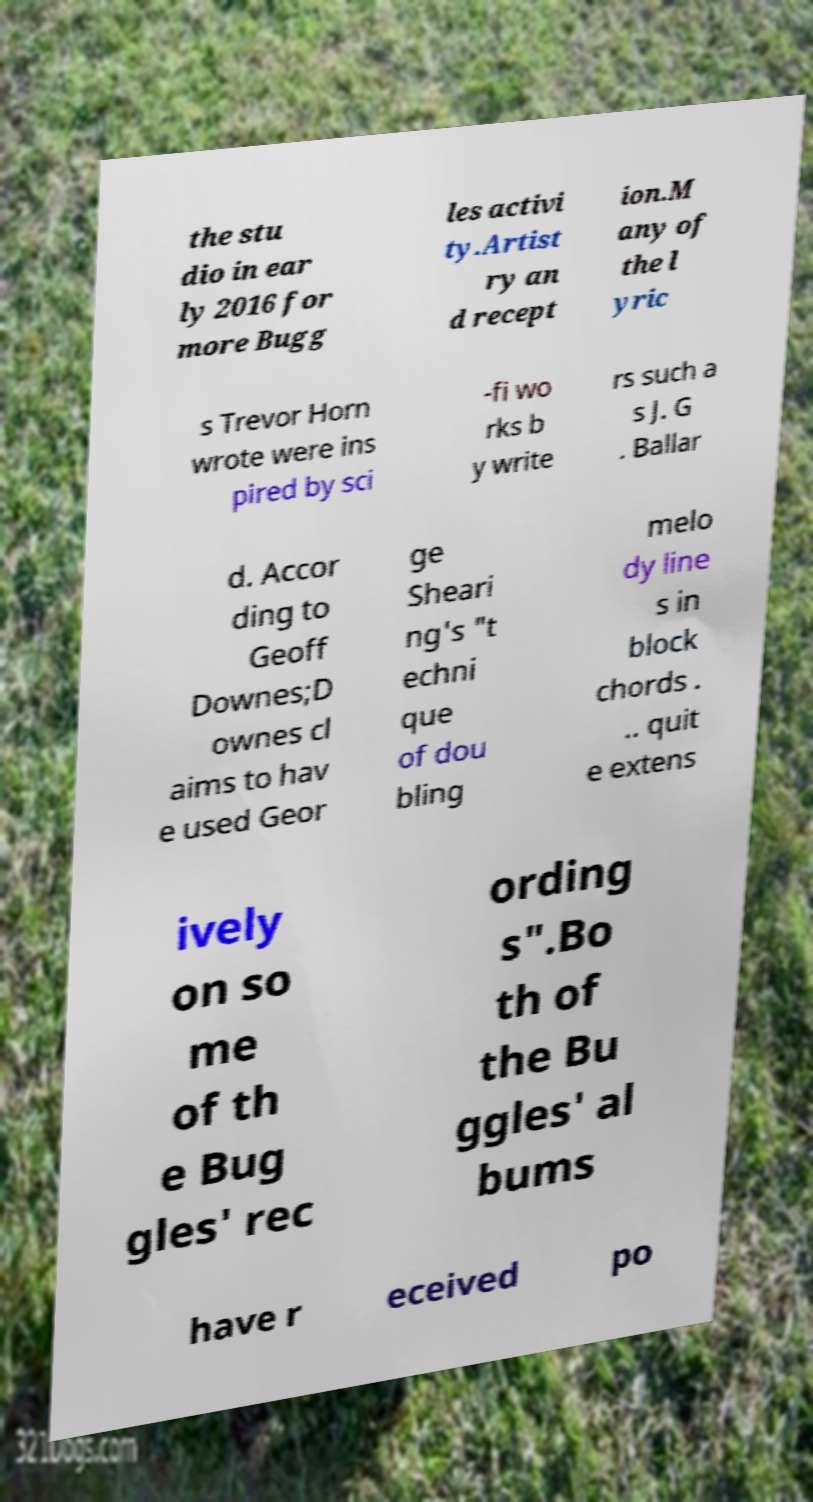Can you read and provide the text displayed in the image?This photo seems to have some interesting text. Can you extract and type it out for me? the stu dio in ear ly 2016 for more Bugg les activi ty.Artist ry an d recept ion.M any of the l yric s Trevor Horn wrote were ins pired by sci -fi wo rks b y write rs such a s J. G . Ballar d. Accor ding to Geoff Downes;D ownes cl aims to hav e used Geor ge Sheari ng's "t echni que of dou bling melo dy line s in block chords . .. quit e extens ively on so me of th e Bug gles' rec ording s".Bo th of the Bu ggles' al bums have r eceived po 